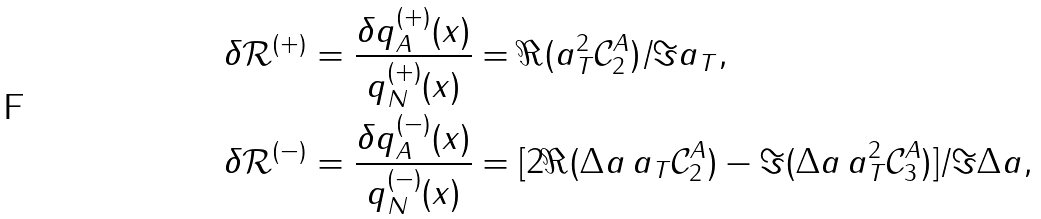Convert formula to latex. <formula><loc_0><loc_0><loc_500><loc_500>\delta \mathcal { R } ^ { ( + ) } & = \frac { \delta q _ { A } ^ { ( + ) } ( x ) } { q _ { N } ^ { ( + ) } ( x ) } = \Re ( a _ { T } ^ { 2 } \mathcal { C } _ { 2 } ^ { A } ) / \Im a _ { T } , \\ \delta \mathcal { R } ^ { ( - ) } & = \frac { \delta q _ { A } ^ { ( - ) } ( x ) } { q _ { N } ^ { ( - ) } ( x ) } = [ 2 \Re ( { \Delta } a \, a _ { T } \mathcal { C } _ { 2 } ^ { A } ) - \Im ( { \Delta } a \, a _ { T } ^ { 2 } \mathcal { C } _ { 3 } ^ { A } ) ] / \Im { \Delta } a ,</formula> 